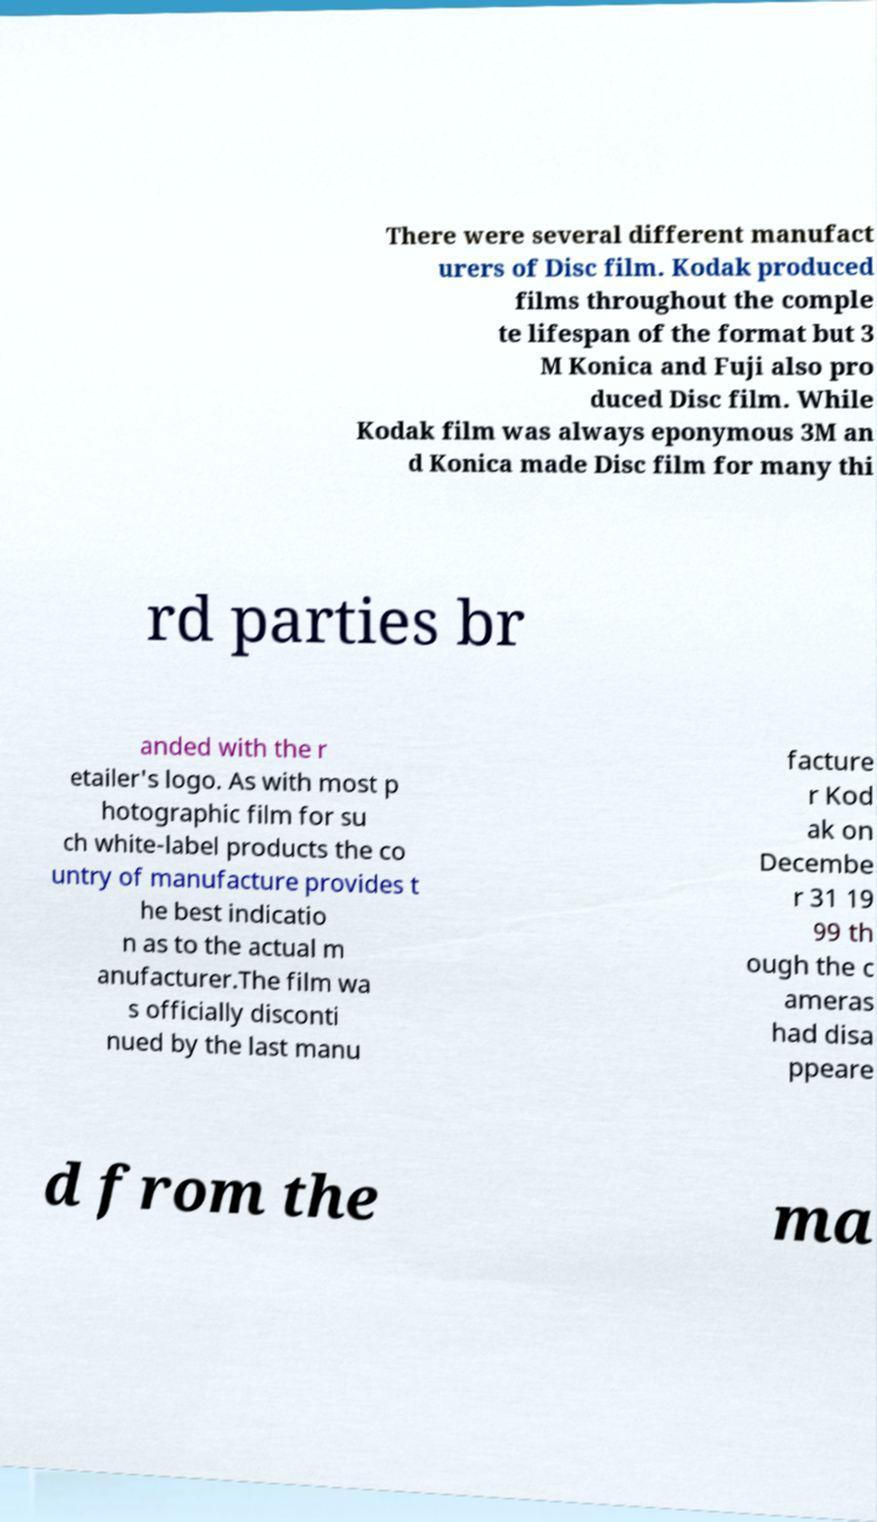Please read and relay the text visible in this image. What does it say? There were several different manufact urers of Disc film. Kodak produced films throughout the comple te lifespan of the format but 3 M Konica and Fuji also pro duced Disc film. While Kodak film was always eponymous 3M an d Konica made Disc film for many thi rd parties br anded with the r etailer's logo. As with most p hotographic film for su ch white-label products the co untry of manufacture provides t he best indicatio n as to the actual m anufacturer.The film wa s officially disconti nued by the last manu facture r Kod ak on Decembe r 31 19 99 th ough the c ameras had disa ppeare d from the ma 